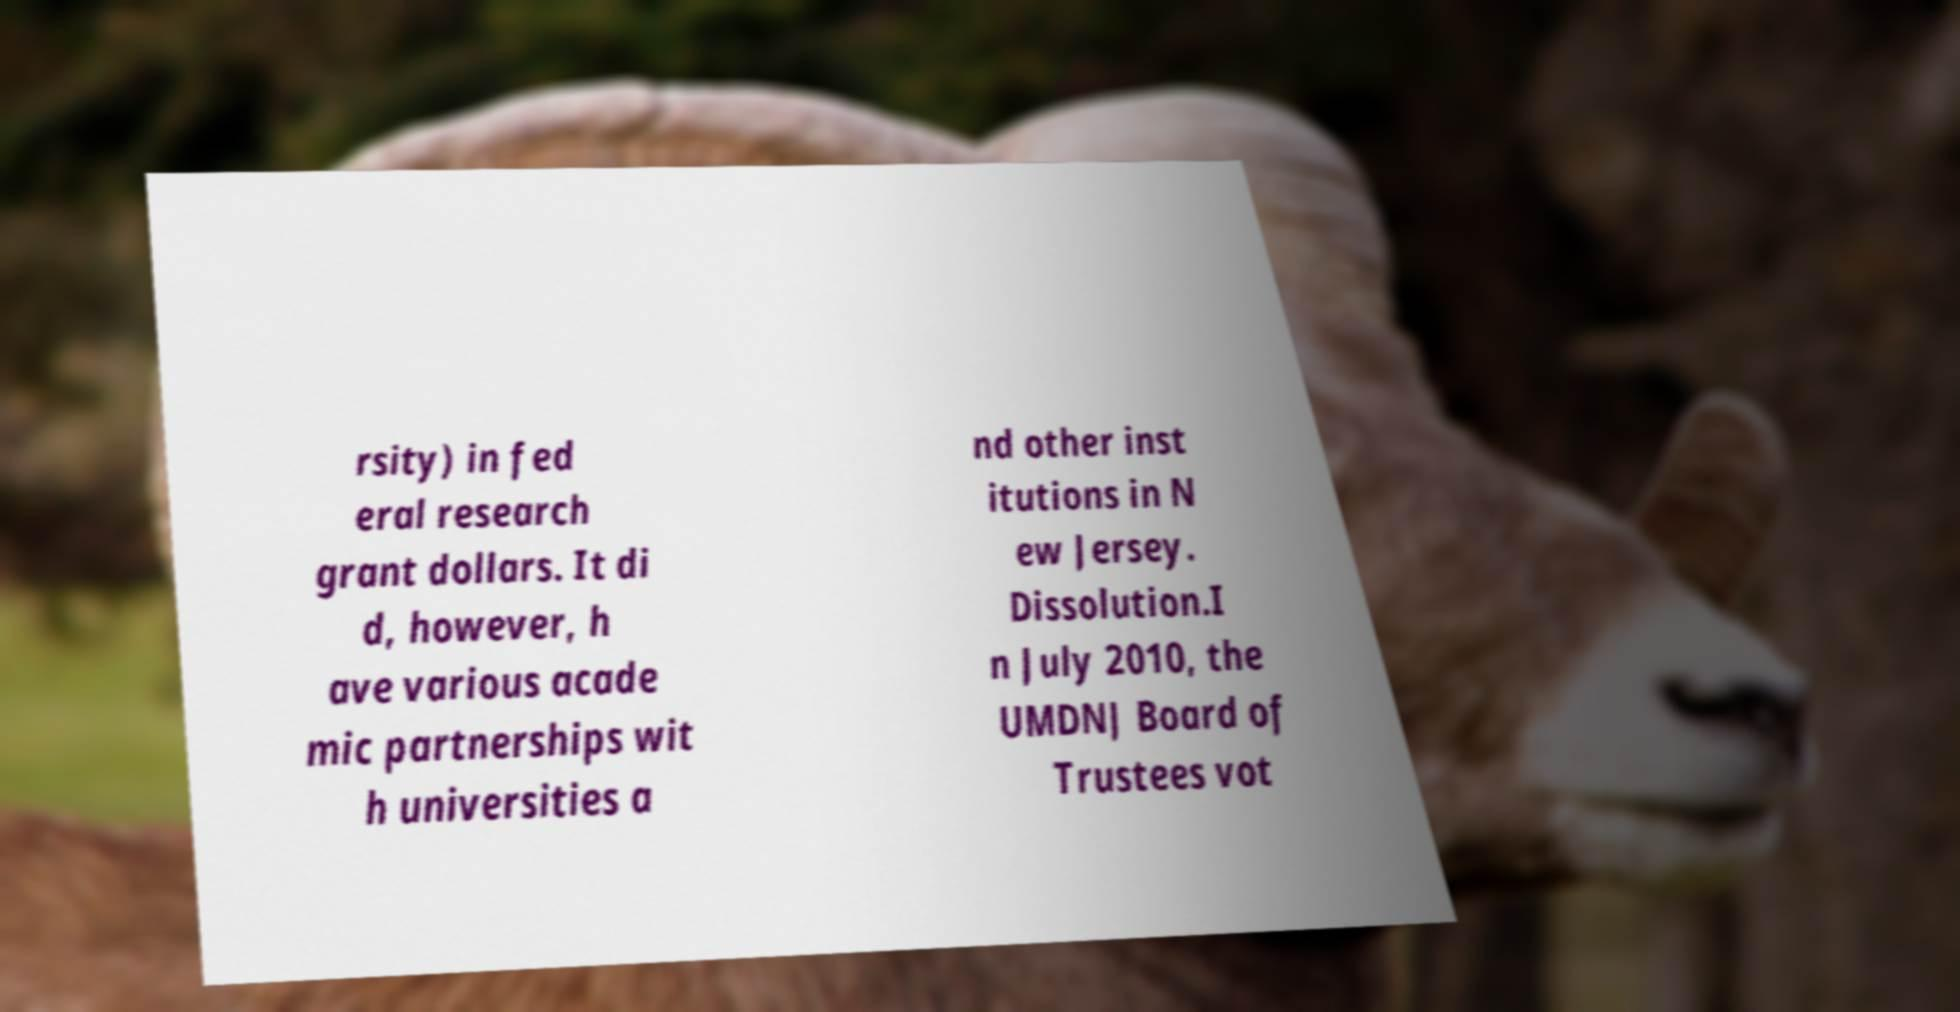Could you assist in decoding the text presented in this image and type it out clearly? rsity) in fed eral research grant dollars. It di d, however, h ave various acade mic partnerships wit h universities a nd other inst itutions in N ew Jersey. Dissolution.I n July 2010, the UMDNJ Board of Trustees vot 